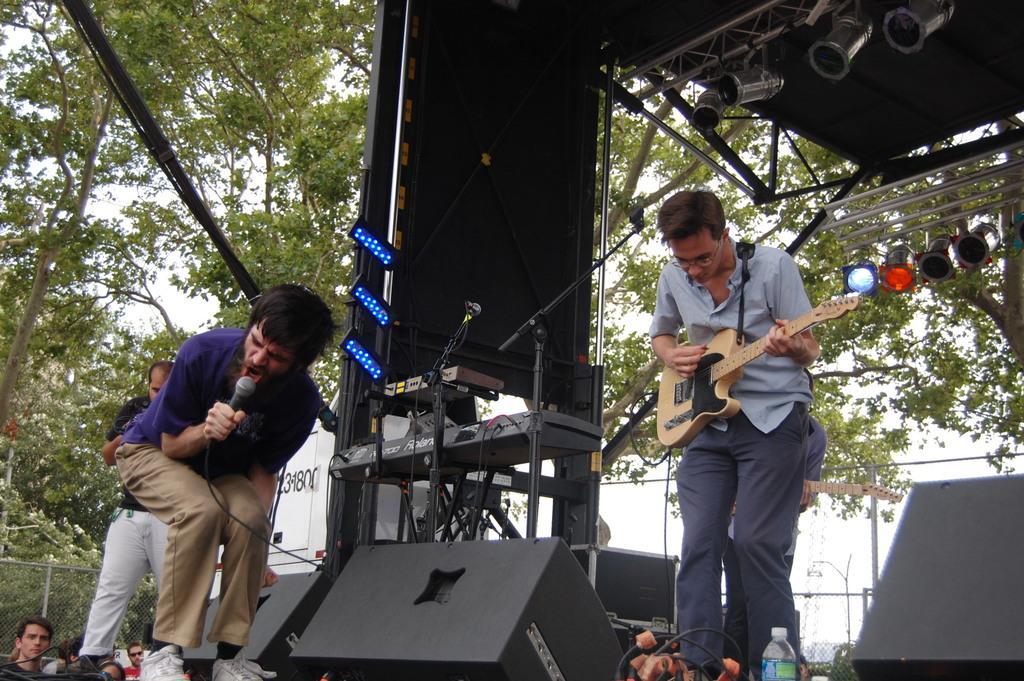In one or two sentences, can you explain what this image depicts? There is a group of people. They are standing. The four persons are playing a musical instruments. On the left side of the person is holding a mic. He is singing a song. We can see in the background trees,and,lights and musical instruments. 